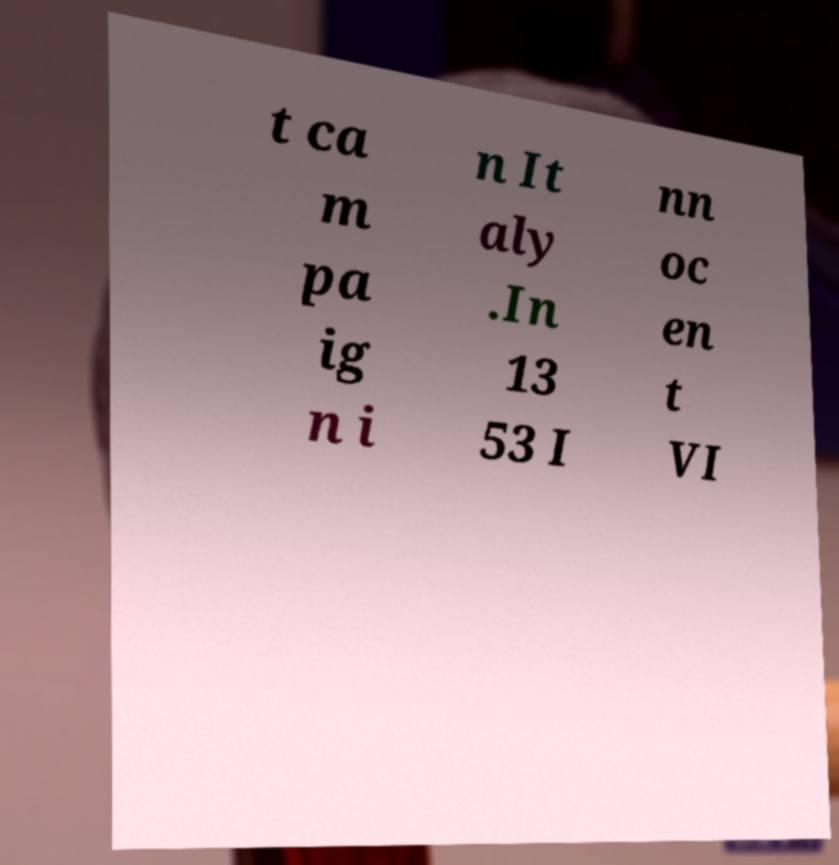What messages or text are displayed in this image? I need them in a readable, typed format. t ca m pa ig n i n It aly .In 13 53 I nn oc en t VI 